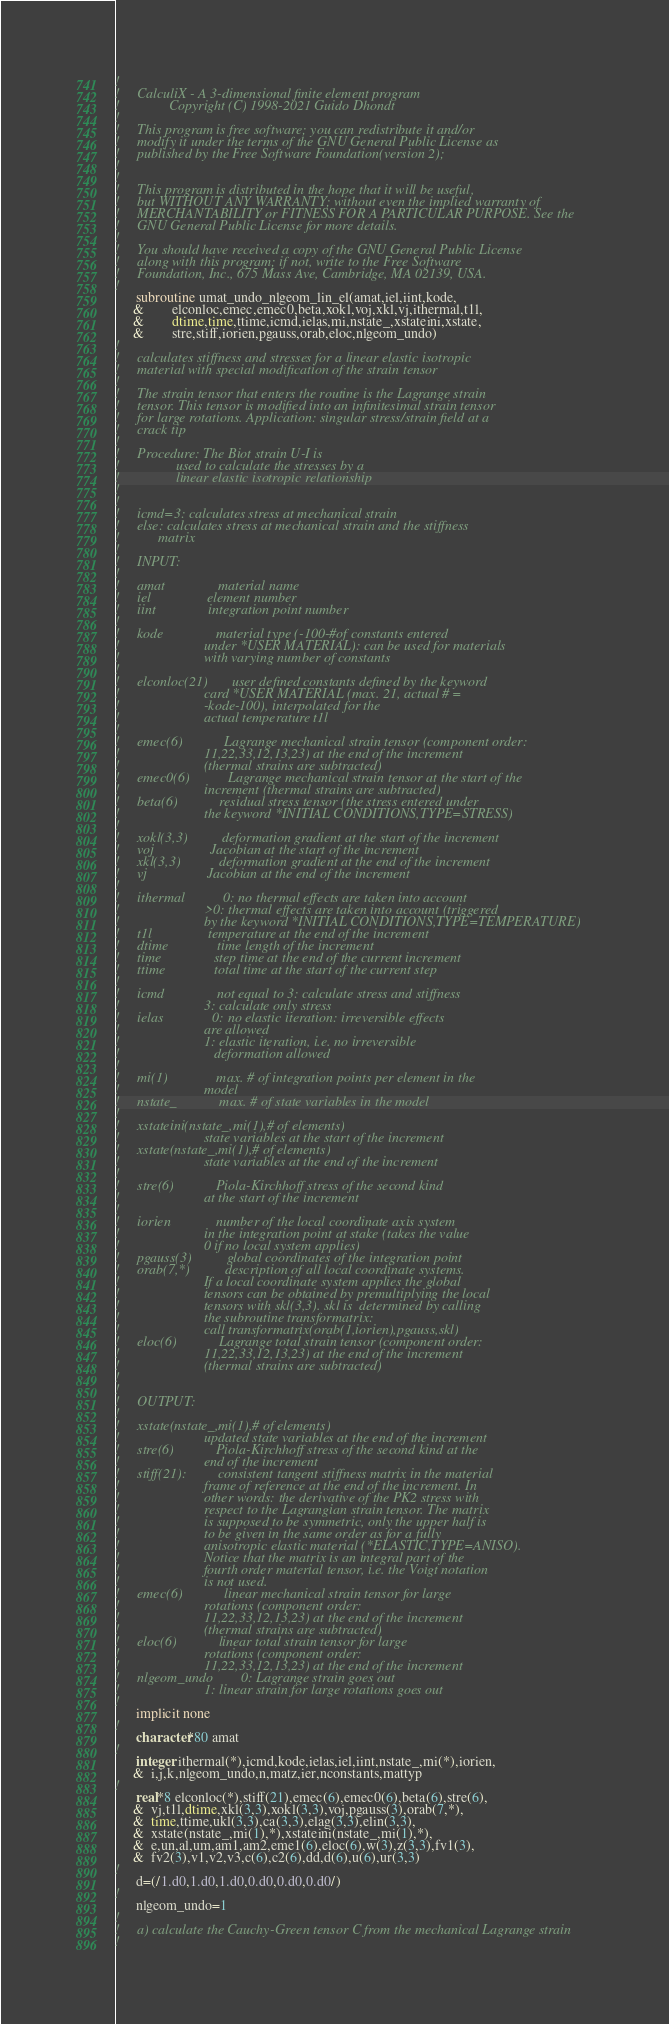Convert code to text. <code><loc_0><loc_0><loc_500><loc_500><_FORTRAN_>!
!     CalculiX - A 3-dimensional finite element program
!              Copyright (C) 1998-2021 Guido Dhondt
!
!     This program is free software; you can redistribute it and/or
!     modify it under the terms of the GNU General Public License as
!     published by the Free Software Foundation(version 2);
!     
!
!     This program is distributed in the hope that it will be useful,
!     but WITHOUT ANY WARRANTY; without even the implied warranty of 
!     MERCHANTABILITY or FITNESS FOR A PARTICULAR PURPOSE. See the
!     GNU General Public License for more details.
!
!     You should have received a copy of the GNU General Public License
!     along with this program; if not, write to the Free Software
!     Foundation, Inc., 675 Mass Ave, Cambridge, MA 02139, USA.
!
      subroutine umat_undo_nlgeom_lin_el(amat,iel,iint,kode,
     &        elconloc,emec,emec0,beta,xokl,voj,xkl,vj,ithermal,t1l,
     &        dtime,time,ttime,icmd,ielas,mi,nstate_,xstateini,xstate,
     &        stre,stiff,iorien,pgauss,orab,eloc,nlgeom_undo)
!
!     calculates stiffness and stresses for a linear elastic isotropic
!     material with special modification of the strain tensor
!
!     The strain tensor that enters the routine is the Lagrange strain
!     tensor. This tensor is modified into an infinitesimal strain tensor
!     for large rotations. Application: singular stress/strain field at a
!     crack tip
!
!     Procedure: The Biot strain U-I is
!                used to calculate the stresses by a
!                linear elastic isotropic relationship
!
!
!     icmd=3: calculates stress at mechanical strain
!     else: calculates stress at mechanical strain and the stiffness
!           matrix
!
!     INPUT:
!
!     amat               material name
!     iel                element number
!     iint               integration point number
!
!     kode               material type (-100-#of constants entered
!                        under *USER MATERIAL): can be used for materials
!                        with varying number of constants
!
!     elconloc(21)       user defined constants defined by the keyword
!                        card *USER MATERIAL (max. 21, actual # =
!                        -kode-100), interpolated for the
!                        actual temperature t1l
!
!     emec(6)            Lagrange mechanical strain tensor (component order:
!                        11,22,33,12,13,23) at the end of the increment
!                        (thermal strains are subtracted)
!     emec0(6)           Lagrange mechanical strain tensor at the start of the
!                        increment (thermal strains are subtracted)
!     beta(6)            residual stress tensor (the stress entered under
!                        the keyword *INITIAL CONDITIONS,TYPE=STRESS)
!
!     xokl(3,3)          deformation gradient at the start of the increment
!     voj                Jacobian at the start of the increment
!     xkl(3,3)           deformation gradient at the end of the increment
!     vj                 Jacobian at the end of the increment
!
!     ithermal           0: no thermal effects are taken into account
!                        >0: thermal effects are taken into account (triggered
!                        by the keyword *INITIAL CONDITIONS,TYPE=TEMPERATURE)
!     t1l                temperature at the end of the increment
!     dtime              time length of the increment
!     time               step time at the end of the current increment
!     ttime              total time at the start of the current step
!
!     icmd               not equal to 3: calculate stress and stiffness
!                        3: calculate only stress
!     ielas              0: no elastic iteration: irreversible effects
!                        are allowed
!                        1: elastic iteration, i.e. no irreversible
!                           deformation allowed
!
!     mi(1)              max. # of integration points per element in the
!                        model
!     nstate_            max. # of state variables in the model
!
!     xstateini(nstate_,mi(1),# of elements)
!                        state variables at the start of the increment
!     xstate(nstate_,mi(1),# of elements)
!                        state variables at the end of the increment
!
!     stre(6)            Piola-Kirchhoff stress of the second kind
!                        at the start of the increment
!
!     iorien             number of the local coordinate axis system
!                        in the integration point at stake (takes the value
!                        0 if no local system applies)
!     pgauss(3)          global coordinates of the integration point
!     orab(7,*)          description of all local coordinate systems.
!                        If a local coordinate system applies the global 
!                        tensors can be obtained by premultiplying the local
!                        tensors with skl(3,3). skl is  determined by calling
!                        the subroutine transformatrix: 
!                        call transformatrix(orab(1,iorien),pgauss,skl)
!     eloc(6)            Lagrange total strain tensor (component order:
!                        11,22,33,12,13,23) at the end of the increment
!                        (thermal strains are subtracted)
!
!
!     OUTPUT:
!
!     xstate(nstate_,mi(1),# of elements)
!                        updated state variables at the end of the increment
!     stre(6)            Piola-Kirchhoff stress of the second kind at the
!                        end of the increment
!     stiff(21):         consistent tangent stiffness matrix in the material
!                        frame of reference at the end of the increment. In
!                        other words: the derivative of the PK2 stress with
!                        respect to the Lagrangian strain tensor. The matrix
!                        is supposed to be symmetric, only the upper half is
!                        to be given in the same order as for a fully
!                        anisotropic elastic material (*ELASTIC,TYPE=ANISO).
!                        Notice that the matrix is an integral part of the 
!                        fourth order material tensor, i.e. the Voigt notation
!                        is not used.
!     emec(6)            linear mechanical strain tensor for large
!                        rotations (component order:
!                        11,22,33,12,13,23) at the end of the increment
!                        (thermal strains are subtracted)
!     eloc(6)            linear total strain tensor for large
!                        rotations (component order:
!                        11,22,33,12,13,23) at the end of the increment
!     nlgeom_undo        0: Lagrange strain goes out
!                        1: linear strain for large rotations goes out
!
      implicit none
!
      character*80 amat
!
      integer ithermal(*),icmd,kode,ielas,iel,iint,nstate_,mi(*),iorien,
     &  i,j,k,nlgeom_undo,n,matz,ier,nconstants,mattyp
!
      real*8 elconloc(*),stiff(21),emec(6),emec0(6),beta(6),stre(6),
     &  vj,t1l,dtime,xkl(3,3),xokl(3,3),voj,pgauss(3),orab(7,*),
     &  time,ttime,ukl(3,3),ca(3,3),elag(3,3),elin(3,3),
     &  xstate(nstate_,mi(1),*),xstateini(nstate_,mi(1),*),
     &  e,un,al,um,am1,am2,eme1(6),eloc(6),w(3),z(3,3),fv1(3),
     &  fv2(3),v1,v2,v3,c(6),c2(6),dd,d(6),u(6),ur(3,3)
!
      d=(/1.d0,1.d0,1.d0,0.d0,0.d0,0.d0/)
!
      nlgeom_undo=1
!
!     a) calculate the Cauchy-Green tensor C from the mechanical Lagrange strain
!</code> 